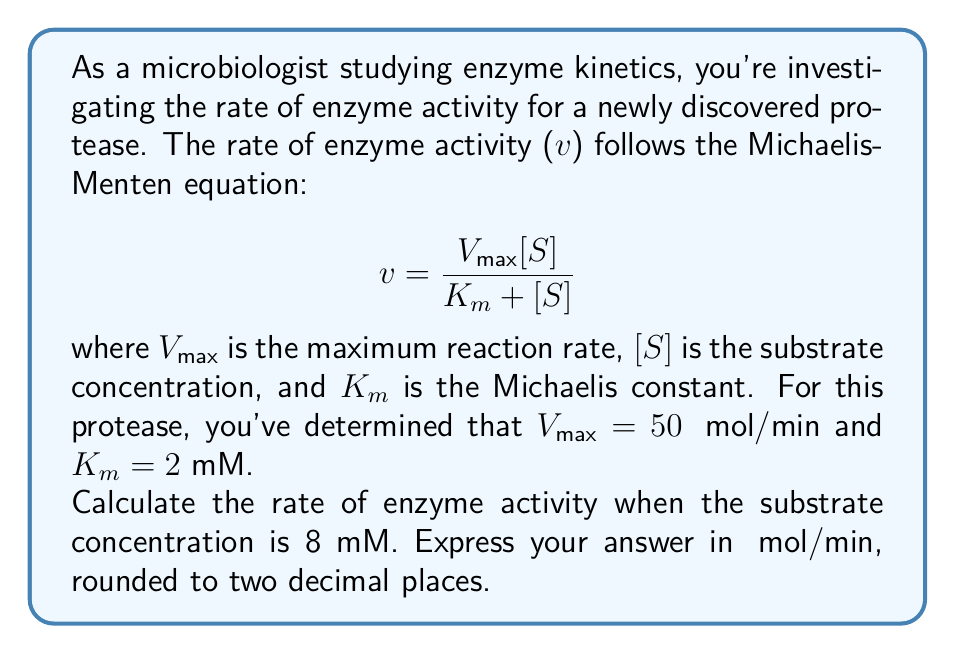Give your solution to this math problem. To solve this problem, we'll use the Michaelis-Menten equation and plug in the given values:

1. Given:
   $V_{max} = 50$ μmol/min
   $K_m = 2$ mM
   $[S] = 8$ mM

2. Michaelis-Menten equation:
   $$ v = \frac{V_{max}[S]}{K_m + [S]} $$

3. Substitute the values into the equation:
   $$ v = \frac{50 \cdot 8}{2 + 8} $$

4. Simplify the numerator and denominator:
   $$ v = \frac{400}{10} $$

5. Perform the division:
   $$ v = 40 $$

Therefore, the rate of enzyme activity at 8 mM substrate concentration is 40 μmol/min.

This result demonstrates that as the substrate concentration increases well above the $K_m$ value, the reaction rate approaches $V_{max}$. In this case, at 8 mM (4 times $K_m$), the reaction rate is 80% of $V_{max}$, showing that the enzyme is operating near its maximum capacity.
Answer: 40.00 μmol/min 